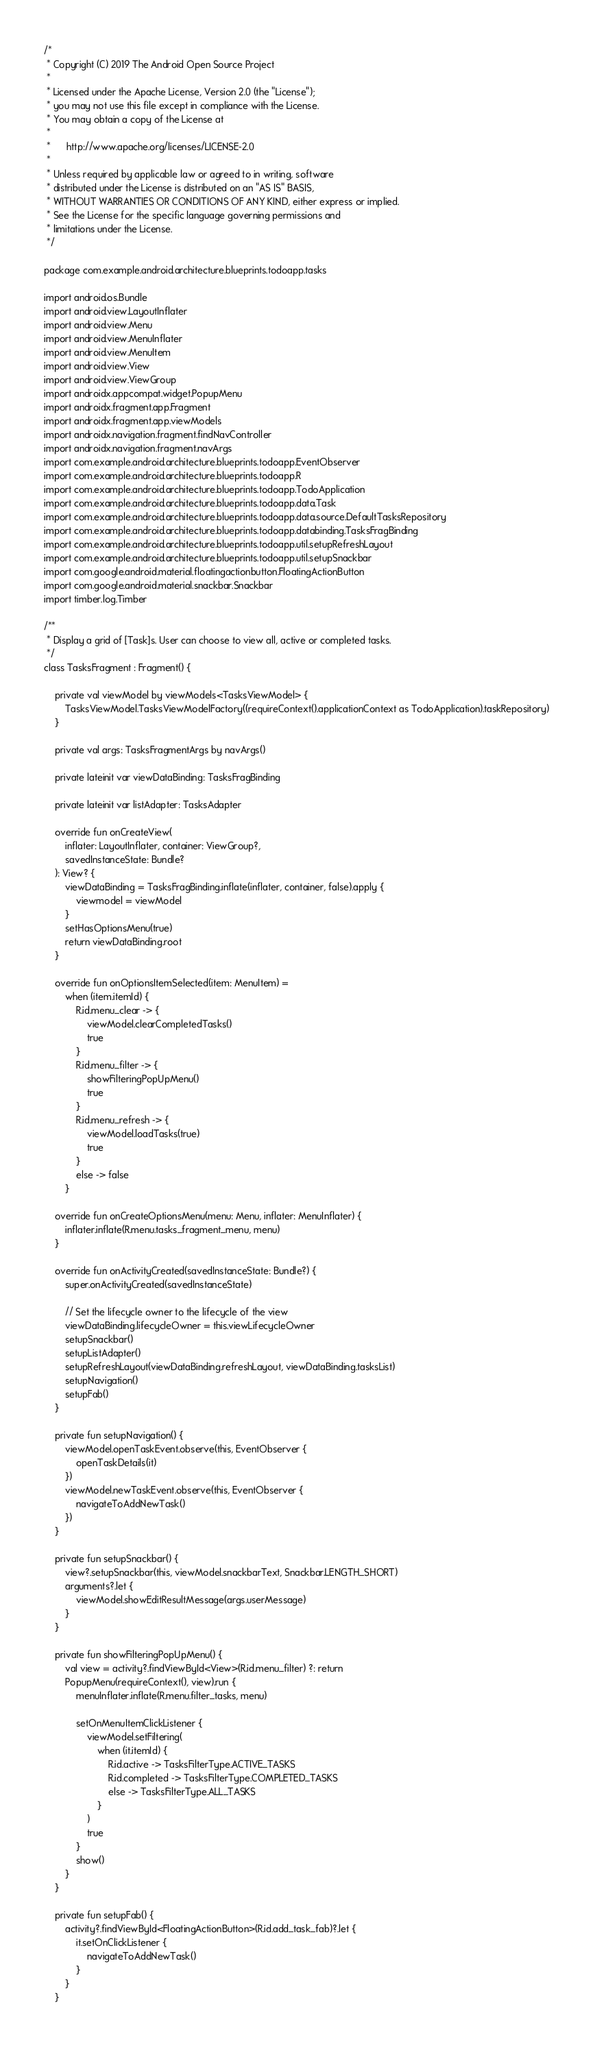<code> <loc_0><loc_0><loc_500><loc_500><_Kotlin_>/*
 * Copyright (C) 2019 The Android Open Source Project
 *
 * Licensed under the Apache License, Version 2.0 (the "License");
 * you may not use this file except in compliance with the License.
 * You may obtain a copy of the License at
 *
 *      http://www.apache.org/licenses/LICENSE-2.0
 *
 * Unless required by applicable law or agreed to in writing, software
 * distributed under the License is distributed on an "AS IS" BASIS,
 * WITHOUT WARRANTIES OR CONDITIONS OF ANY KIND, either express or implied.
 * See the License for the specific language governing permissions and
 * limitations under the License.
 */

package com.example.android.architecture.blueprints.todoapp.tasks

import android.os.Bundle
import android.view.LayoutInflater
import android.view.Menu
import android.view.MenuInflater
import android.view.MenuItem
import android.view.View
import android.view.ViewGroup
import androidx.appcompat.widget.PopupMenu
import androidx.fragment.app.Fragment
import androidx.fragment.app.viewModels
import androidx.navigation.fragment.findNavController
import androidx.navigation.fragment.navArgs
import com.example.android.architecture.blueprints.todoapp.EventObserver
import com.example.android.architecture.blueprints.todoapp.R
import com.example.android.architecture.blueprints.todoapp.TodoApplication
import com.example.android.architecture.blueprints.todoapp.data.Task
import com.example.android.architecture.blueprints.todoapp.data.source.DefaultTasksRepository
import com.example.android.architecture.blueprints.todoapp.databinding.TasksFragBinding
import com.example.android.architecture.blueprints.todoapp.util.setupRefreshLayout
import com.example.android.architecture.blueprints.todoapp.util.setupSnackbar
import com.google.android.material.floatingactionbutton.FloatingActionButton
import com.google.android.material.snackbar.Snackbar
import timber.log.Timber

/**
 * Display a grid of [Task]s. User can choose to view all, active or completed tasks.
 */
class TasksFragment : Fragment() {

    private val viewModel by viewModels<TasksViewModel> {
        TasksViewModel.TasksViewModelFactory((requireContext().applicationContext as TodoApplication).taskRepository)
    }

    private val args: TasksFragmentArgs by navArgs()

    private lateinit var viewDataBinding: TasksFragBinding

    private lateinit var listAdapter: TasksAdapter

    override fun onCreateView(
        inflater: LayoutInflater, container: ViewGroup?,
        savedInstanceState: Bundle?
    ): View? {
        viewDataBinding = TasksFragBinding.inflate(inflater, container, false).apply {
            viewmodel = viewModel
        }
        setHasOptionsMenu(true)
        return viewDataBinding.root
    }

    override fun onOptionsItemSelected(item: MenuItem) =
        when (item.itemId) {
            R.id.menu_clear -> {
                viewModel.clearCompletedTasks()
                true
            }
            R.id.menu_filter -> {
                showFilteringPopUpMenu()
                true
            }
            R.id.menu_refresh -> {
                viewModel.loadTasks(true)
                true
            }
            else -> false
        }

    override fun onCreateOptionsMenu(menu: Menu, inflater: MenuInflater) {
        inflater.inflate(R.menu.tasks_fragment_menu, menu)
    }

    override fun onActivityCreated(savedInstanceState: Bundle?) {
        super.onActivityCreated(savedInstanceState)

        // Set the lifecycle owner to the lifecycle of the view
        viewDataBinding.lifecycleOwner = this.viewLifecycleOwner
        setupSnackbar()
        setupListAdapter()
        setupRefreshLayout(viewDataBinding.refreshLayout, viewDataBinding.tasksList)
        setupNavigation()
        setupFab()
    }

    private fun setupNavigation() {
        viewModel.openTaskEvent.observe(this, EventObserver {
            openTaskDetails(it)
        })
        viewModel.newTaskEvent.observe(this, EventObserver {
            navigateToAddNewTask()
        })
    }

    private fun setupSnackbar() {
        view?.setupSnackbar(this, viewModel.snackbarText, Snackbar.LENGTH_SHORT)
        arguments?.let {
            viewModel.showEditResultMessage(args.userMessage)
        }
    }

    private fun showFilteringPopUpMenu() {
        val view = activity?.findViewById<View>(R.id.menu_filter) ?: return
        PopupMenu(requireContext(), view).run {
            menuInflater.inflate(R.menu.filter_tasks, menu)

            setOnMenuItemClickListener {
                viewModel.setFiltering(
                    when (it.itemId) {
                        R.id.active -> TasksFilterType.ACTIVE_TASKS
                        R.id.completed -> TasksFilterType.COMPLETED_TASKS
                        else -> TasksFilterType.ALL_TASKS
                    }
                )
                true
            }
            show()
        }
    }

    private fun setupFab() {
        activity?.findViewById<FloatingActionButton>(R.id.add_task_fab)?.let {
            it.setOnClickListener {
                navigateToAddNewTask()
            }
        }
    }
</code> 